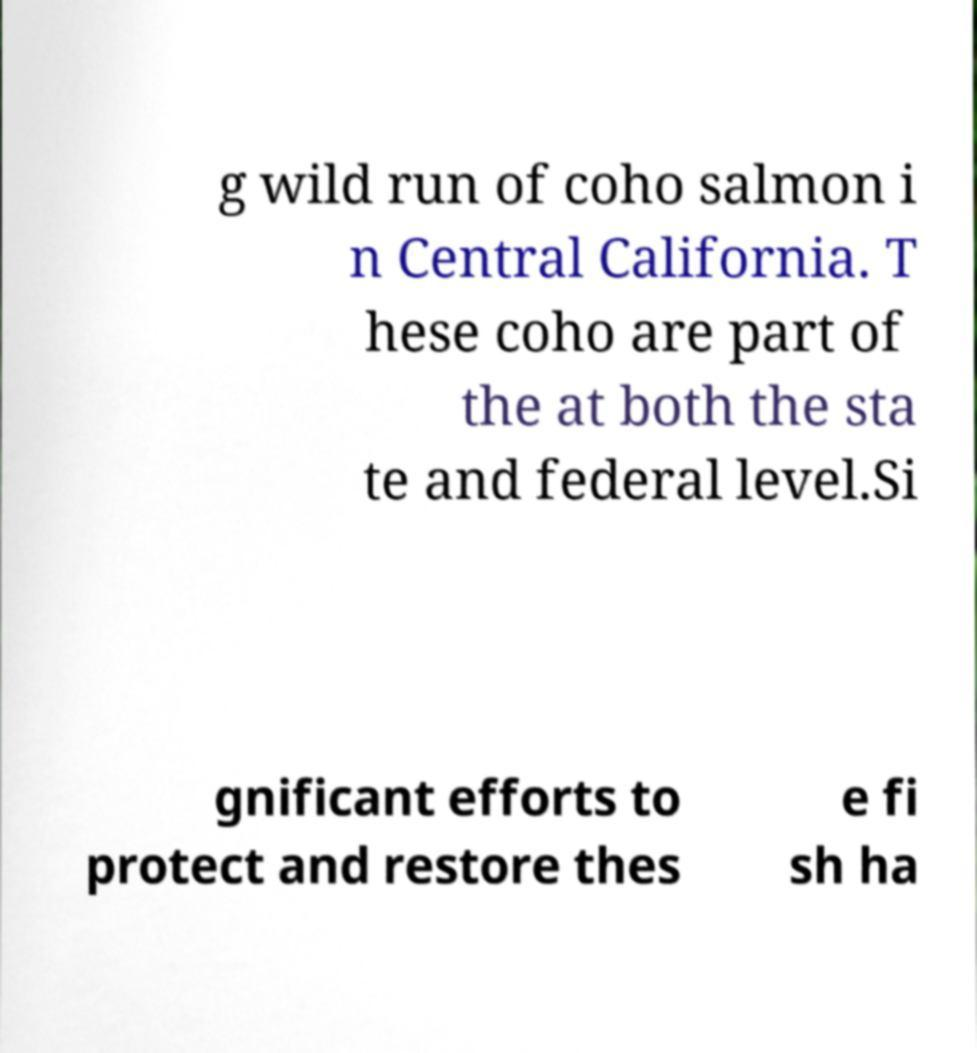There's text embedded in this image that I need extracted. Can you transcribe it verbatim? g wild run of coho salmon i n Central California. T hese coho are part of the at both the sta te and federal level.Si gnificant efforts to protect and restore thes e fi sh ha 